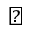Convert formula to latex. <formula><loc_0><loc_0><loc_500><loc_500>\natural</formula> 